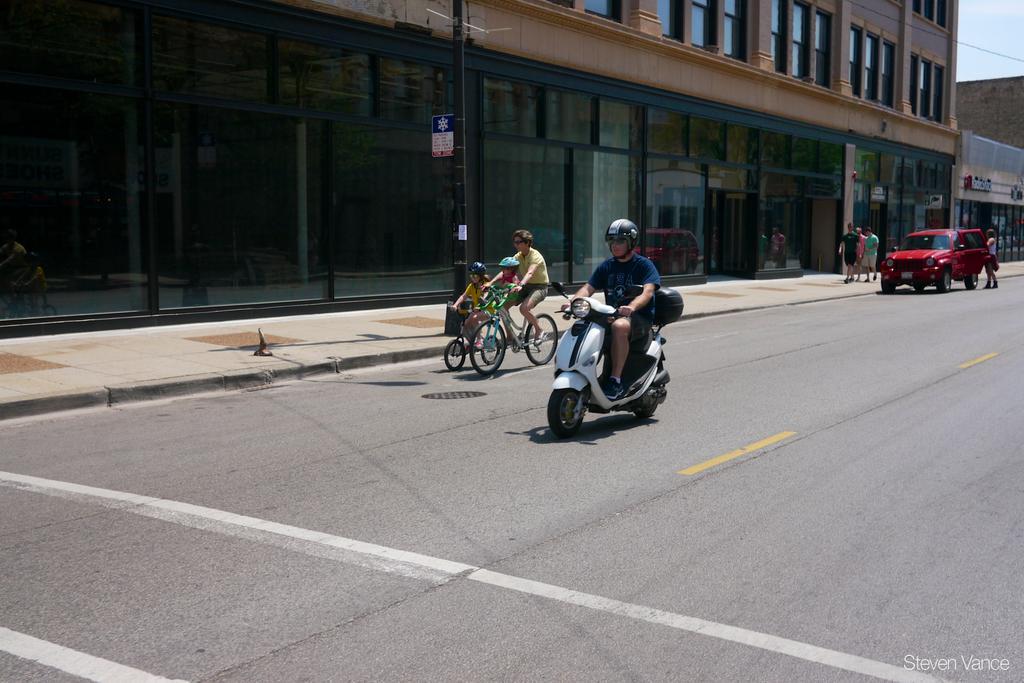Could you give a brief overview of what you see in this image? In this picture we can see a car, man wore a helmet and riding a motorbike, two people riding bicycles on the road, some people walking on a footpath, buildings with windows, sign boards and in the background we can see the sky. 